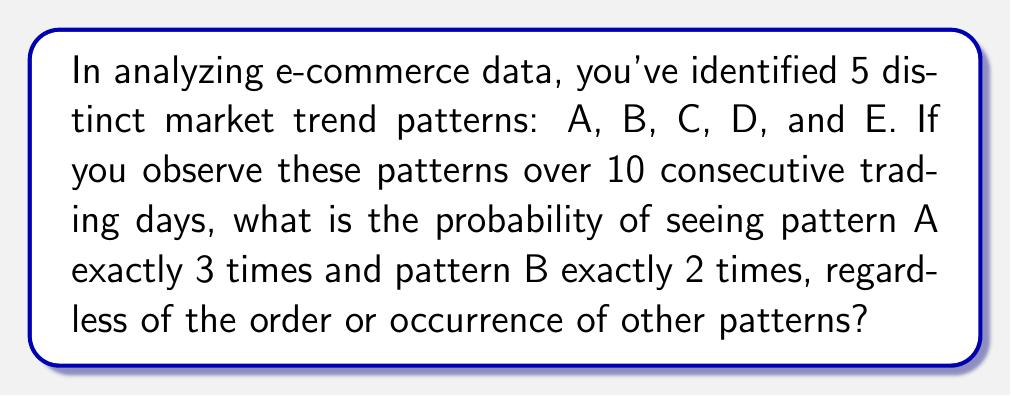Teach me how to tackle this problem. Let's approach this step-by-step:

1) This is a problem of multinomial distribution, where we're interested in specific occurrences of two outcomes (A and B) out of five possible outcomes (A, B, C, D, E) over 10 trials.

2) We need to calculate:
   a) The number of ways to arrange 3 A's and 2 B's in 10 slots
   b) The probability of each specific arrangement
   c) Multiply these together

3) The number of ways to arrange 3 A's and 2 B's in 10 slots is given by the multinomial coefficient:

   $$\binom{10}{3,2,5} = \frac{10!}{3!2!5!}$$

4) The probability of each specific arrangement:
   - Probability of A occurring: $\frac{1}{5}$
   - Probability of B occurring: $\frac{1}{5}$
   - Probability of neither A nor B occurring: $\frac{3}{5}$

   So, the probability of a specific arrangement is:

   $$(\frac{1}{5})^3 \cdot (\frac{1}{5})^2 \cdot (\frac{3}{5})^5$$

5) Multiplying these together:

   $$P = \frac{10!}{3!2!5!} \cdot (\frac{1}{5})^3 \cdot (\frac{1}{5})^2 \cdot (\frac{3}{5})^5$$

6) Simplifying:

   $$P = \frac{10!}{3!2!5!} \cdot \frac{1}{5^5} \cdot 3^5$$

   $$P = \frac{10 \cdot 9 \cdot 8 \cdot 7 \cdot 6}{(3 \cdot 2 \cdot 1)(2 \cdot 1)} \cdot \frac{3^5}{5^5}$$

   $$P = 2520 \cdot \frac{243}{3125} = 0.196128$$
Answer: $\frac{2520 \cdot 243}{3125} \approx 0.196128$ 